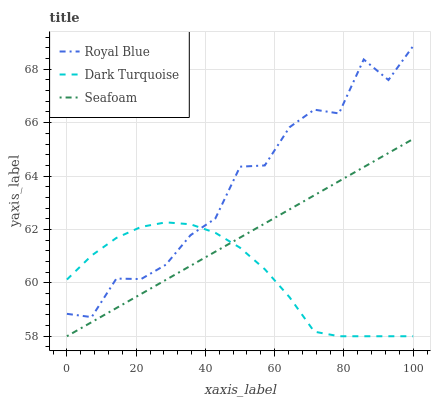Does Dark Turquoise have the minimum area under the curve?
Answer yes or no. Yes. Does Royal Blue have the maximum area under the curve?
Answer yes or no. Yes. Does Seafoam have the minimum area under the curve?
Answer yes or no. No. Does Seafoam have the maximum area under the curve?
Answer yes or no. No. Is Seafoam the smoothest?
Answer yes or no. Yes. Is Royal Blue the roughest?
Answer yes or no. Yes. Is Dark Turquoise the smoothest?
Answer yes or no. No. Is Dark Turquoise the roughest?
Answer yes or no. No. Does Seafoam have the lowest value?
Answer yes or no. Yes. Does Royal Blue have the highest value?
Answer yes or no. Yes. Does Seafoam have the highest value?
Answer yes or no. No. Is Seafoam less than Royal Blue?
Answer yes or no. Yes. Is Royal Blue greater than Seafoam?
Answer yes or no. Yes. Does Royal Blue intersect Dark Turquoise?
Answer yes or no. Yes. Is Royal Blue less than Dark Turquoise?
Answer yes or no. No. Is Royal Blue greater than Dark Turquoise?
Answer yes or no. No. Does Seafoam intersect Royal Blue?
Answer yes or no. No. 